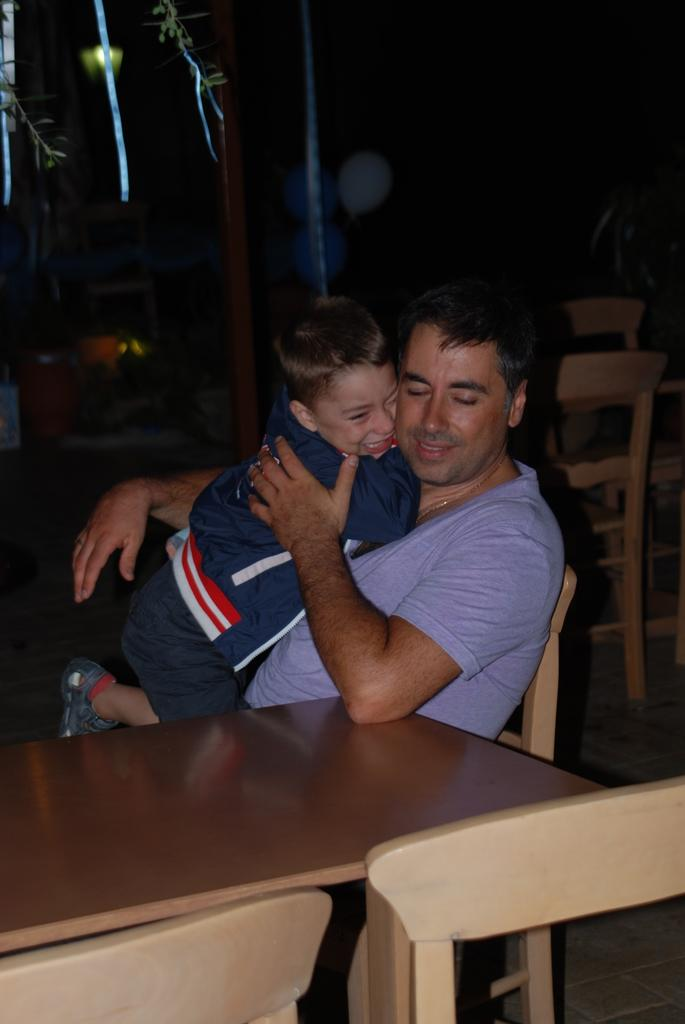What is the main subject of the image? The main subject of the image is a man. What is the man doing in the image? The man is sitting on a chair and holding a boy. What furniture can be seen in the image? There is a table and chairs in the image. What objects are visible in the background of the image? In the background, there are chairs, balloons, a pole, and a light. How does the man wash the button in the image? There is no button present in the image, and the man is not washing anything. Is it raining in the image? There is no indication of rain in the image. 